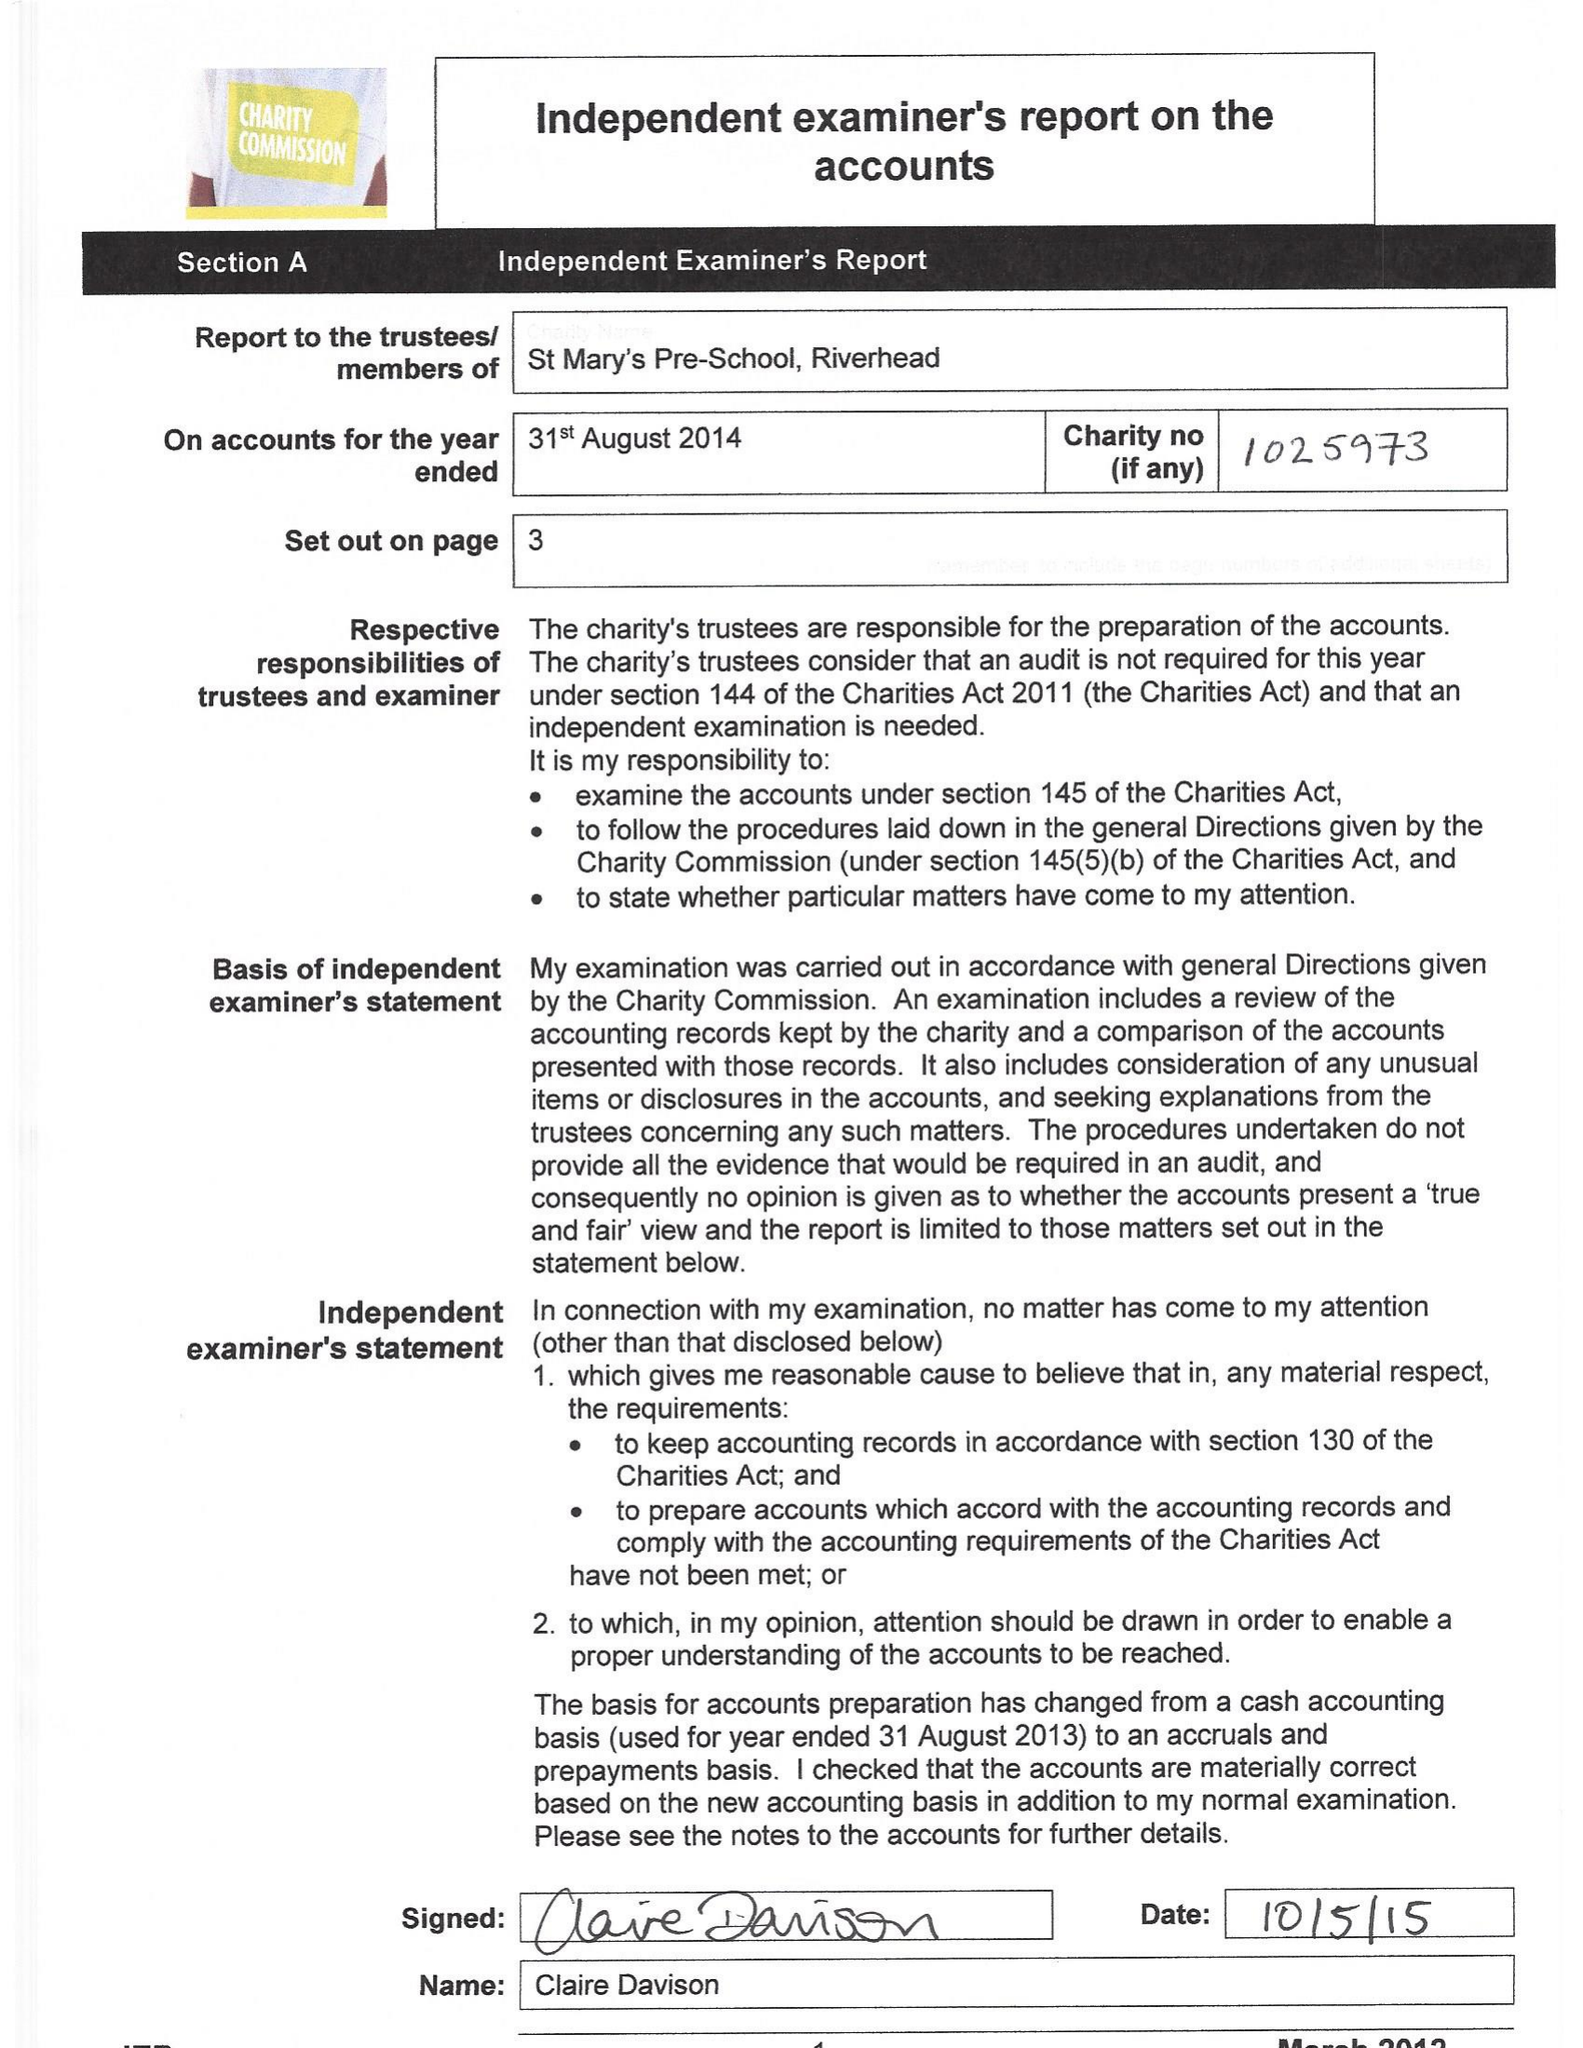What is the value for the address__postcode?
Answer the question using a single word or phrase. TN14 5RB 